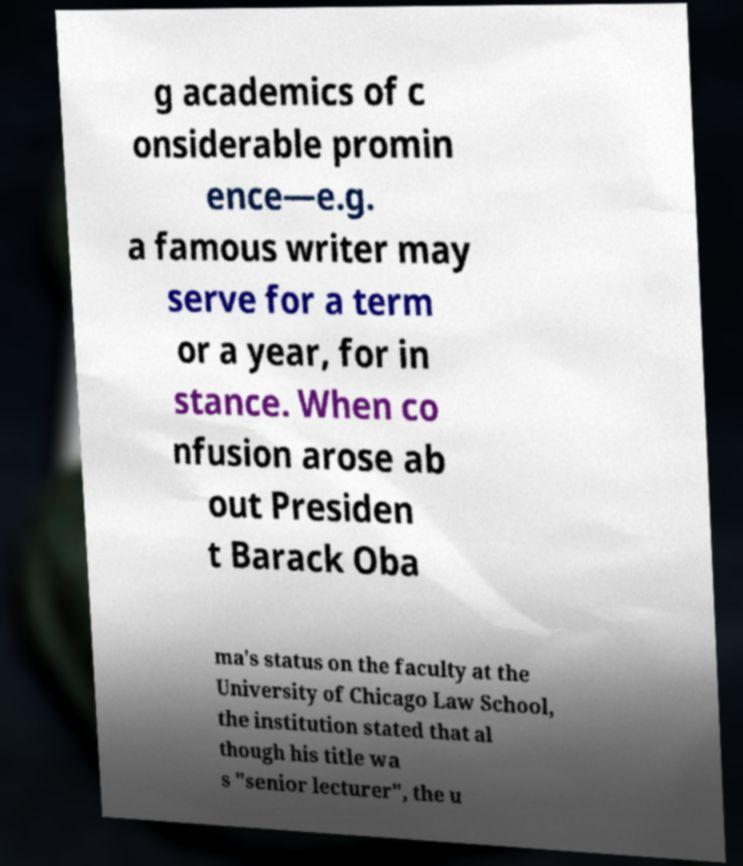Please identify and transcribe the text found in this image. g academics of c onsiderable promin ence—e.g. a famous writer may serve for a term or a year, for in stance. When co nfusion arose ab out Presiden t Barack Oba ma's status on the faculty at the University of Chicago Law School, the institution stated that al though his title wa s "senior lecturer", the u 